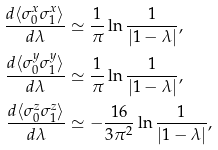<formula> <loc_0><loc_0><loc_500><loc_500>\frac { d \langle \sigma _ { 0 } ^ { x } \sigma _ { 1 } ^ { x } \rangle } { d \lambda } & \simeq \frac { 1 } { \pi } \ln \frac { 1 } { \left | 1 - \lambda \right | } , \\ \frac { d \langle \sigma _ { 0 } ^ { y } \sigma _ { 1 } ^ { y } \rangle } { d \lambda } & \simeq \frac { 1 } { \pi } \ln \frac { 1 } { \left | 1 - \lambda \right | } , \\ \frac { d \langle \sigma _ { 0 } ^ { z } \sigma _ { 1 } ^ { z } \rangle } { d \lambda } & \simeq - \frac { 1 6 } { 3 \pi ^ { 2 } } \ln \frac { 1 } { \left | 1 - \lambda \right | } ,</formula> 